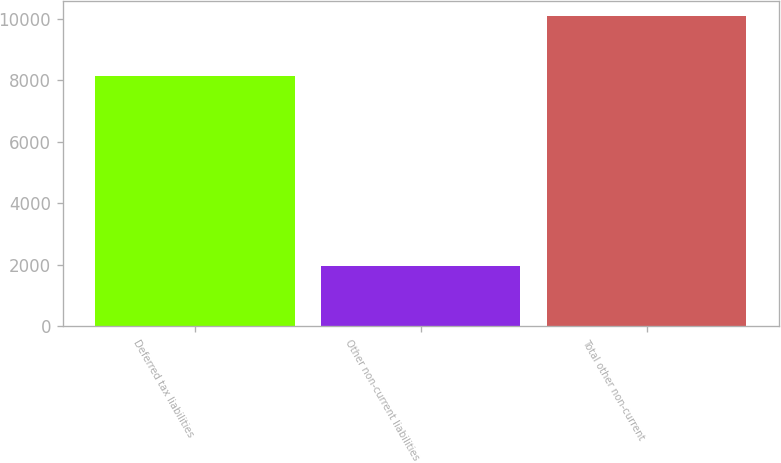Convert chart. <chart><loc_0><loc_0><loc_500><loc_500><bar_chart><fcel>Deferred tax liabilities<fcel>Other non-current liabilities<fcel>Total other non-current<nl><fcel>8159<fcel>1941<fcel>10100<nl></chart> 